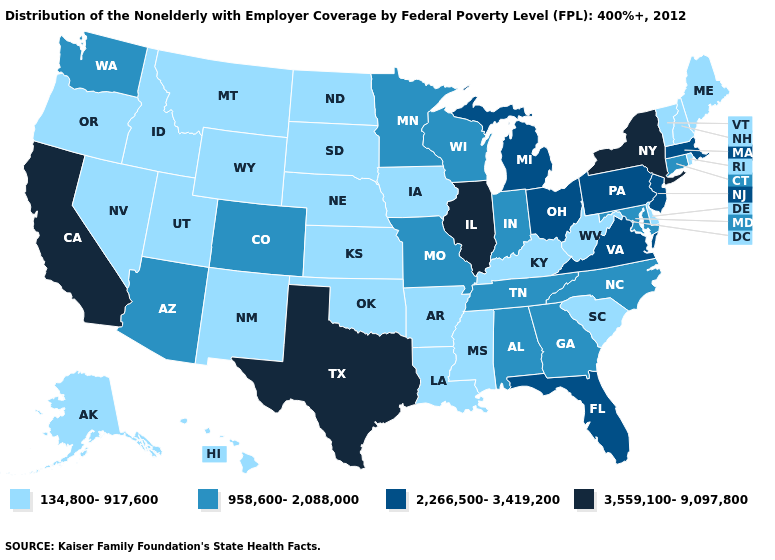Among the states that border South Dakota , does Wyoming have the lowest value?
Concise answer only. Yes. Does Minnesota have the highest value in the MidWest?
Write a very short answer. No. Which states hav the highest value in the MidWest?
Short answer required. Illinois. Does New York have the lowest value in the USA?
Concise answer only. No. Among the states that border Tennessee , which have the highest value?
Write a very short answer. Virginia. Does Wyoming have a lower value than Colorado?
Answer briefly. Yes. What is the lowest value in the USA?
Be succinct. 134,800-917,600. What is the value of Delaware?
Short answer required. 134,800-917,600. Name the states that have a value in the range 2,266,500-3,419,200?
Write a very short answer. Florida, Massachusetts, Michigan, New Jersey, Ohio, Pennsylvania, Virginia. Is the legend a continuous bar?
Concise answer only. No. Which states have the lowest value in the Northeast?
Be succinct. Maine, New Hampshire, Rhode Island, Vermont. Does the first symbol in the legend represent the smallest category?
Write a very short answer. Yes. Does the first symbol in the legend represent the smallest category?
Short answer required. Yes. Which states have the lowest value in the USA?
Give a very brief answer. Alaska, Arkansas, Delaware, Hawaii, Idaho, Iowa, Kansas, Kentucky, Louisiana, Maine, Mississippi, Montana, Nebraska, Nevada, New Hampshire, New Mexico, North Dakota, Oklahoma, Oregon, Rhode Island, South Carolina, South Dakota, Utah, Vermont, West Virginia, Wyoming. Which states hav the highest value in the MidWest?
Be succinct. Illinois. 